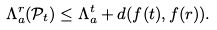Convert formula to latex. <formula><loc_0><loc_0><loc_500><loc_500>\Lambda _ { a } ^ { r } ( \mathcal { P } _ { t } ) \leq \Lambda _ { a } ^ { t } + d ( f ( t ) , f ( r ) ) .</formula> 